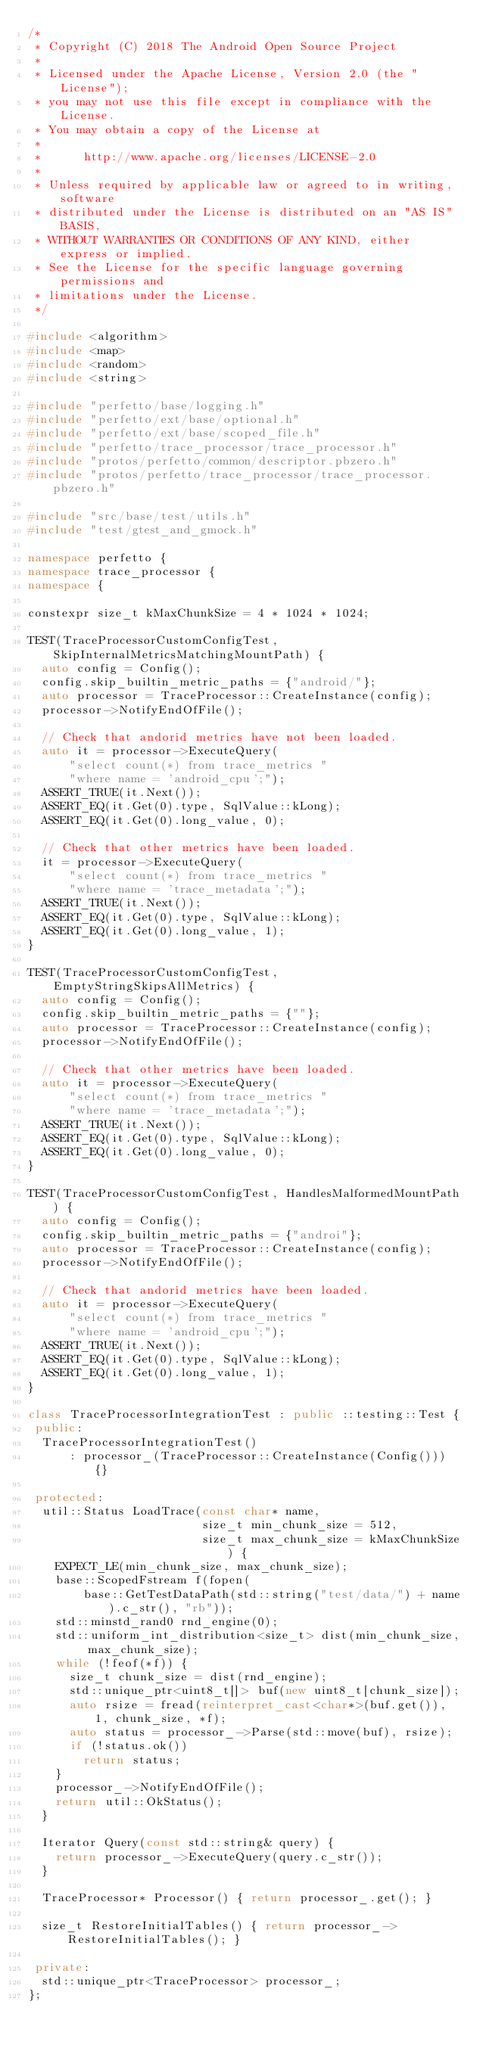<code> <loc_0><loc_0><loc_500><loc_500><_C++_>/*
 * Copyright (C) 2018 The Android Open Source Project
 *
 * Licensed under the Apache License, Version 2.0 (the "License");
 * you may not use this file except in compliance with the License.
 * You may obtain a copy of the License at
 *
 *      http://www.apache.org/licenses/LICENSE-2.0
 *
 * Unless required by applicable law or agreed to in writing, software
 * distributed under the License is distributed on an "AS IS" BASIS,
 * WITHOUT WARRANTIES OR CONDITIONS OF ANY KIND, either express or implied.
 * See the License for the specific language governing permissions and
 * limitations under the License.
 */

#include <algorithm>
#include <map>
#include <random>
#include <string>

#include "perfetto/base/logging.h"
#include "perfetto/ext/base/optional.h"
#include "perfetto/ext/base/scoped_file.h"
#include "perfetto/trace_processor/trace_processor.h"
#include "protos/perfetto/common/descriptor.pbzero.h"
#include "protos/perfetto/trace_processor/trace_processor.pbzero.h"

#include "src/base/test/utils.h"
#include "test/gtest_and_gmock.h"

namespace perfetto {
namespace trace_processor {
namespace {

constexpr size_t kMaxChunkSize = 4 * 1024 * 1024;

TEST(TraceProcessorCustomConfigTest, SkipInternalMetricsMatchingMountPath) {
  auto config = Config();
  config.skip_builtin_metric_paths = {"android/"};
  auto processor = TraceProcessor::CreateInstance(config);
  processor->NotifyEndOfFile();

  // Check that andorid metrics have not been loaded.
  auto it = processor->ExecuteQuery(
      "select count(*) from trace_metrics "
      "where name = 'android_cpu';");
  ASSERT_TRUE(it.Next());
  ASSERT_EQ(it.Get(0).type, SqlValue::kLong);
  ASSERT_EQ(it.Get(0).long_value, 0);

  // Check that other metrics have been loaded.
  it = processor->ExecuteQuery(
      "select count(*) from trace_metrics "
      "where name = 'trace_metadata';");
  ASSERT_TRUE(it.Next());
  ASSERT_EQ(it.Get(0).type, SqlValue::kLong);
  ASSERT_EQ(it.Get(0).long_value, 1);
}

TEST(TraceProcessorCustomConfigTest, EmptyStringSkipsAllMetrics) {
  auto config = Config();
  config.skip_builtin_metric_paths = {""};
  auto processor = TraceProcessor::CreateInstance(config);
  processor->NotifyEndOfFile();

  // Check that other metrics have been loaded.
  auto it = processor->ExecuteQuery(
      "select count(*) from trace_metrics "
      "where name = 'trace_metadata';");
  ASSERT_TRUE(it.Next());
  ASSERT_EQ(it.Get(0).type, SqlValue::kLong);
  ASSERT_EQ(it.Get(0).long_value, 0);
}

TEST(TraceProcessorCustomConfigTest, HandlesMalformedMountPath) {
  auto config = Config();
  config.skip_builtin_metric_paths = {"androi"};
  auto processor = TraceProcessor::CreateInstance(config);
  processor->NotifyEndOfFile();

  // Check that andorid metrics have been loaded.
  auto it = processor->ExecuteQuery(
      "select count(*) from trace_metrics "
      "where name = 'android_cpu';");
  ASSERT_TRUE(it.Next());
  ASSERT_EQ(it.Get(0).type, SqlValue::kLong);
  ASSERT_EQ(it.Get(0).long_value, 1);
}

class TraceProcessorIntegrationTest : public ::testing::Test {
 public:
  TraceProcessorIntegrationTest()
      : processor_(TraceProcessor::CreateInstance(Config())) {}

 protected:
  util::Status LoadTrace(const char* name,
                         size_t min_chunk_size = 512,
                         size_t max_chunk_size = kMaxChunkSize) {
    EXPECT_LE(min_chunk_size, max_chunk_size);
    base::ScopedFstream f(fopen(
        base::GetTestDataPath(std::string("test/data/") + name).c_str(), "rb"));
    std::minstd_rand0 rnd_engine(0);
    std::uniform_int_distribution<size_t> dist(min_chunk_size, max_chunk_size);
    while (!feof(*f)) {
      size_t chunk_size = dist(rnd_engine);
      std::unique_ptr<uint8_t[]> buf(new uint8_t[chunk_size]);
      auto rsize = fread(reinterpret_cast<char*>(buf.get()), 1, chunk_size, *f);
      auto status = processor_->Parse(std::move(buf), rsize);
      if (!status.ok())
        return status;
    }
    processor_->NotifyEndOfFile();
    return util::OkStatus();
  }

  Iterator Query(const std::string& query) {
    return processor_->ExecuteQuery(query.c_str());
  }

  TraceProcessor* Processor() { return processor_.get(); }

  size_t RestoreInitialTables() { return processor_->RestoreInitialTables(); }

 private:
  std::unique_ptr<TraceProcessor> processor_;
};
</code> 